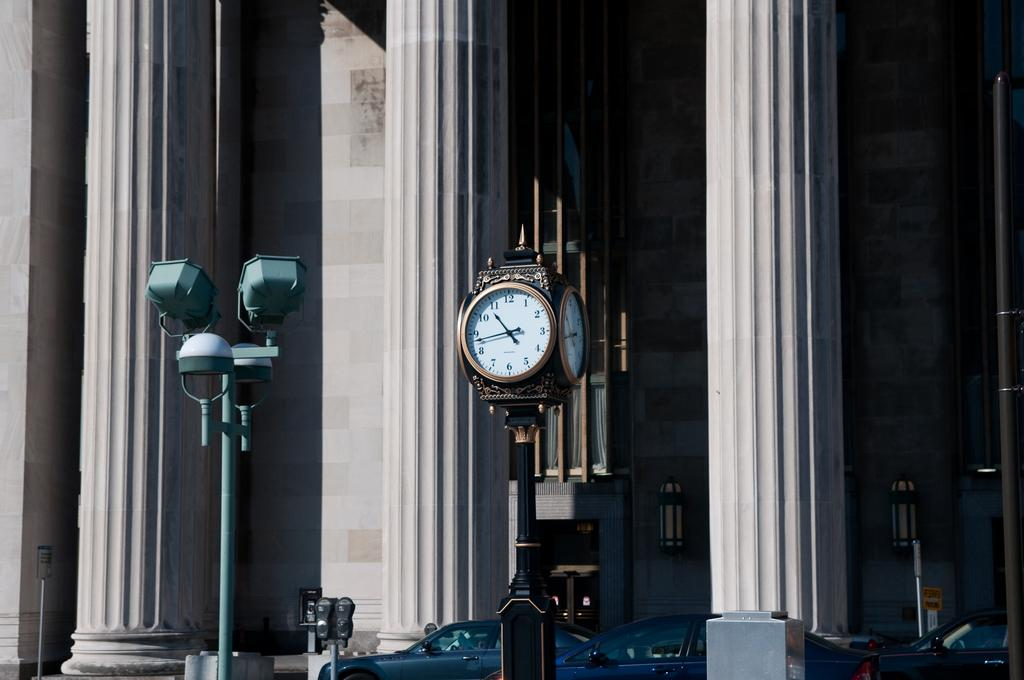<image>
Render a clear and concise summary of the photo. A clock displays the  time as quarter to eleven. 